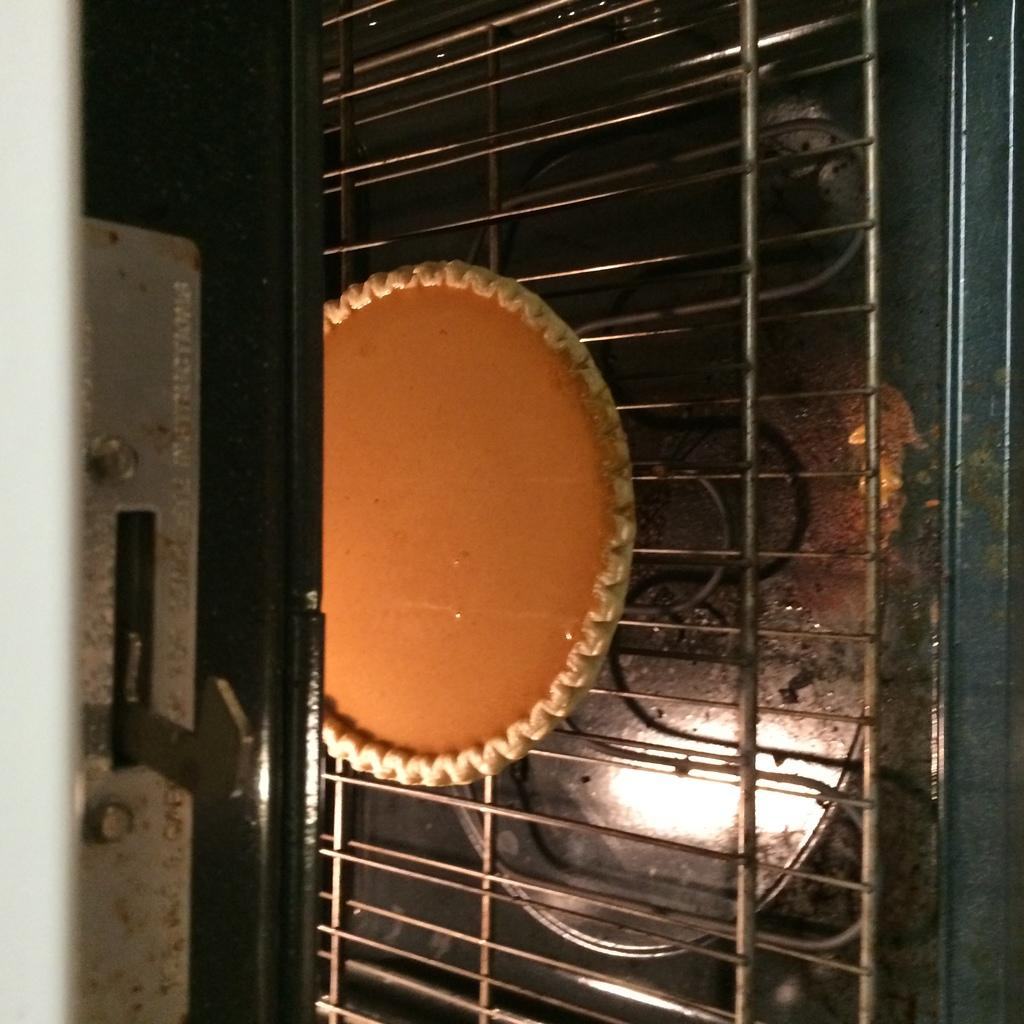What is the main object in the image? There is a baking pan in the image. Where is the baking pan located? The baking pan is in an oven. What else can be seen in the image? There are grills visible in the image. What type of health advice can be seen written on the baking pan in the image? There is no health advice written on the baking pan in the image; it is a baking pan in an oven with grills visible. 